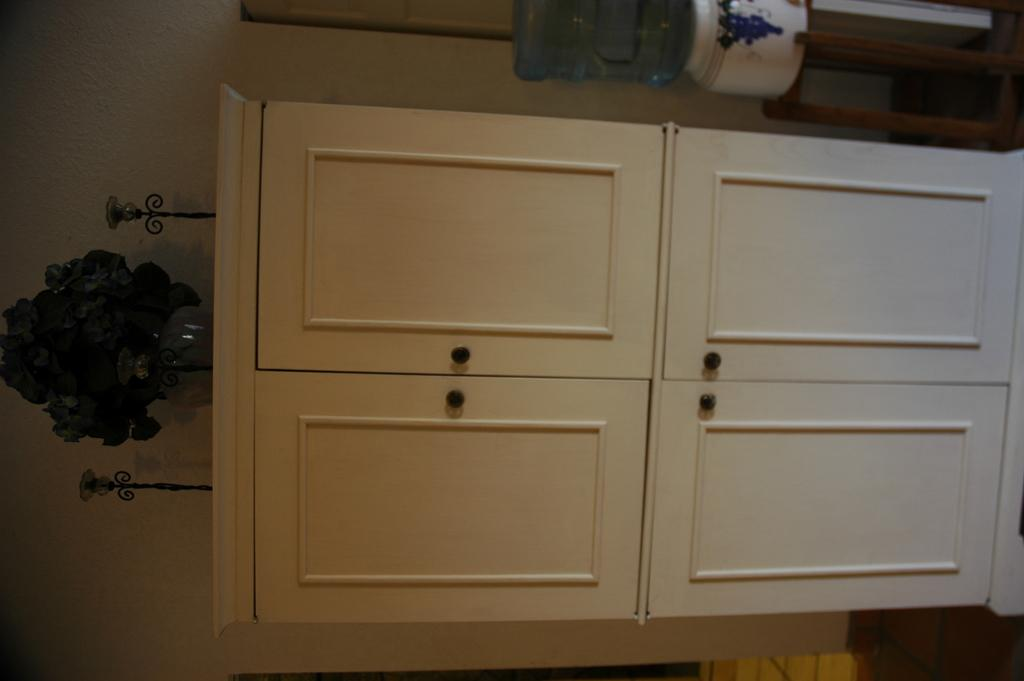What is the main object in the image? There is a flower flask in the image. What type of furniture can be seen in the image? There are cupboards in the image. What can be seen in the background of the image? There is a wall visible in the background of the image. What is on the table in the background of the image? There is an object on a table in the background of the image. How many bridges can be seen in the image? There are no bridges present in the image. What type of grass is growing on the wall in the image? There is no grass growing on the wall in the image. 